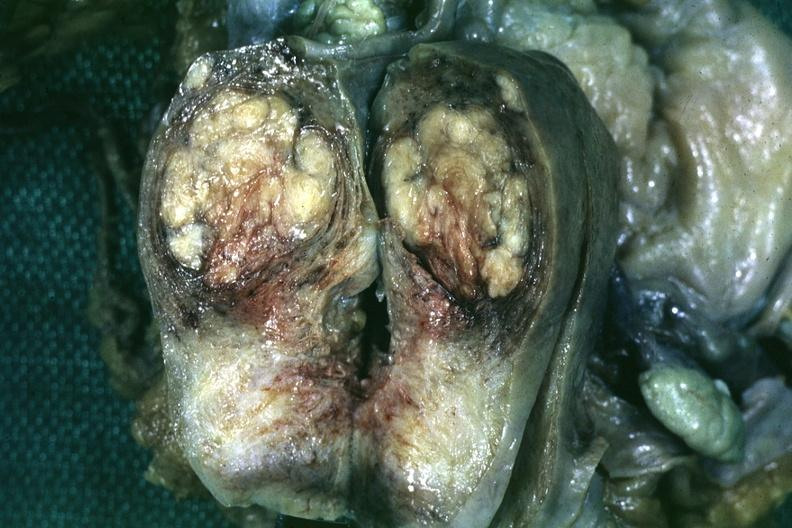where does this belong to?
Answer the question using a single word or phrase. Female reproductive system 